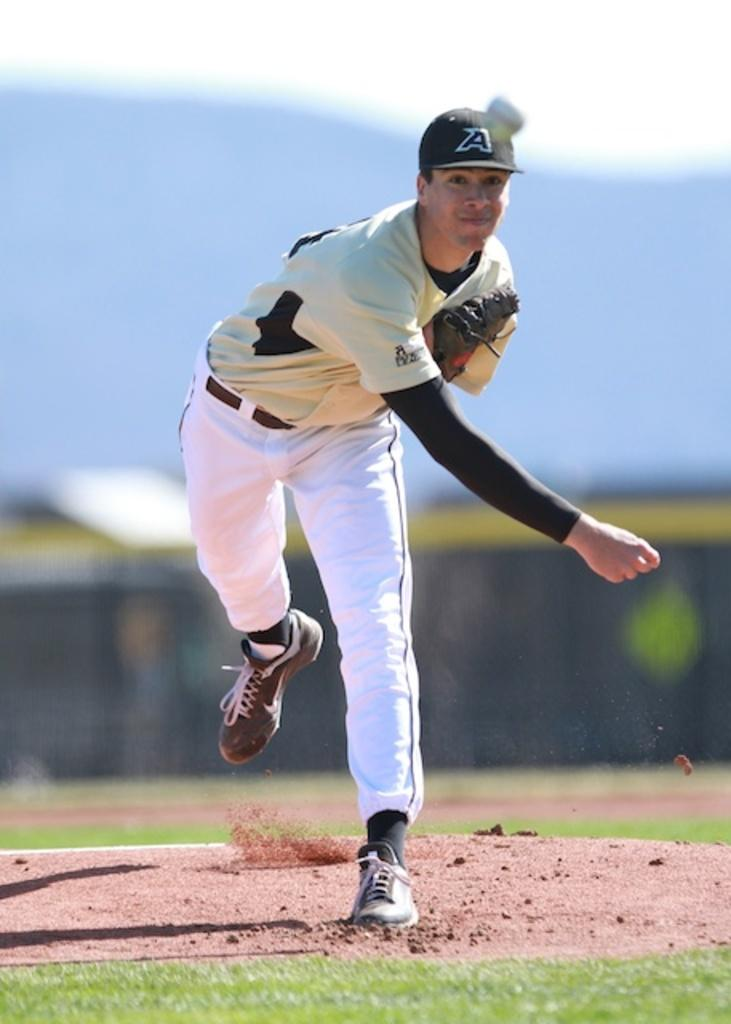Provide a one-sentence caption for the provided image. a baseball pitcher on the mound from the A team. 